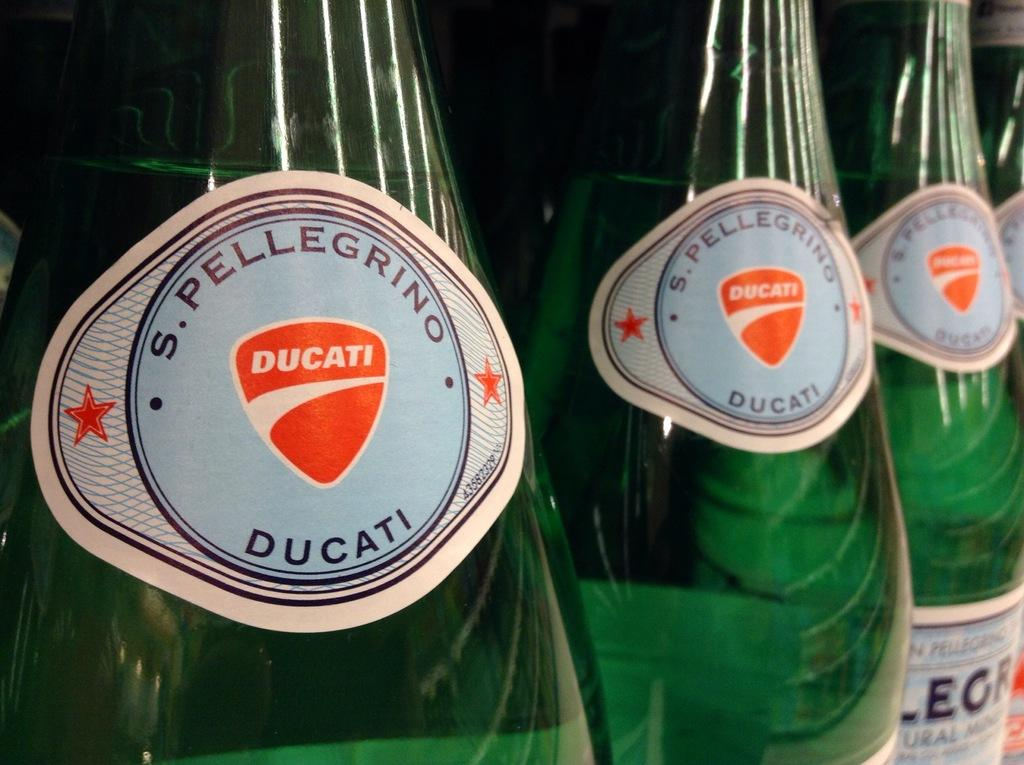<image>
Summarize the visual content of the image. Green bottles of S. Pellegrino Ducati in a row 